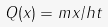Convert formula to latex. <formula><loc_0><loc_0><loc_500><loc_500>Q ( x ) = m x / h t</formula> 